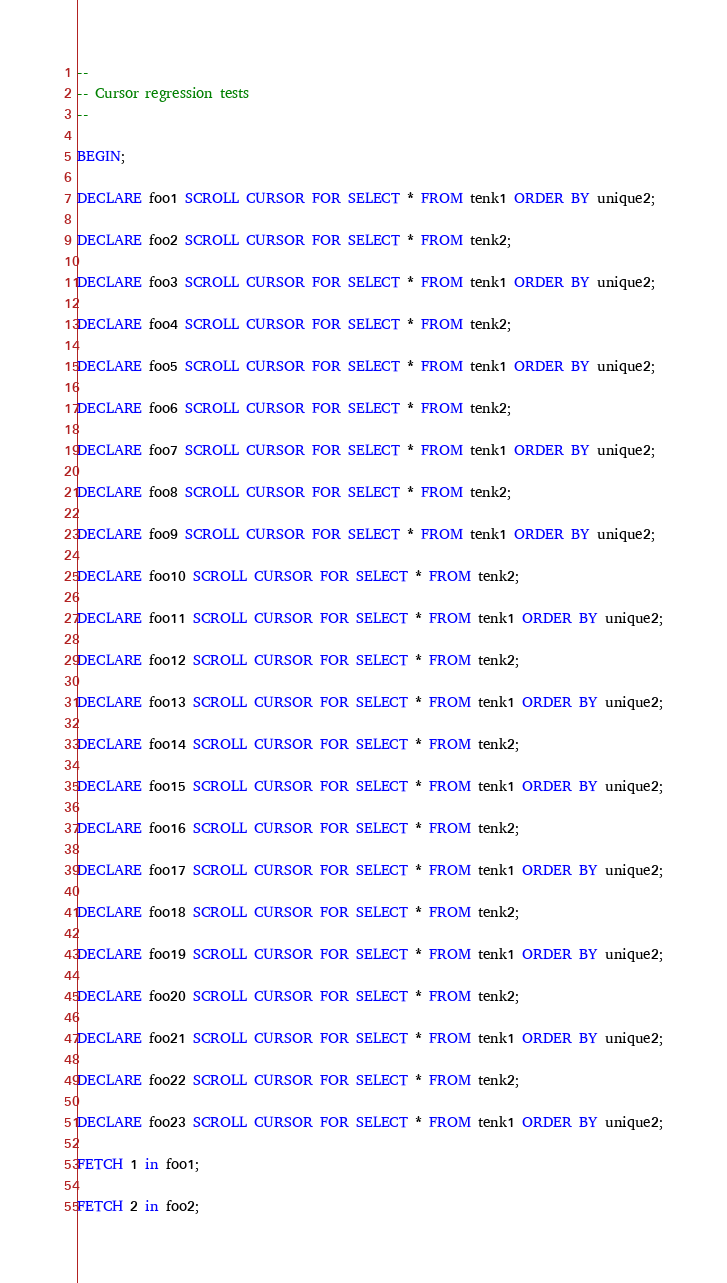Convert code to text. <code><loc_0><loc_0><loc_500><loc_500><_SQL_>--
-- Cursor regression tests
--

BEGIN;

DECLARE foo1 SCROLL CURSOR FOR SELECT * FROM tenk1 ORDER BY unique2;

DECLARE foo2 SCROLL CURSOR FOR SELECT * FROM tenk2;

DECLARE foo3 SCROLL CURSOR FOR SELECT * FROM tenk1 ORDER BY unique2;

DECLARE foo4 SCROLL CURSOR FOR SELECT * FROM tenk2;

DECLARE foo5 SCROLL CURSOR FOR SELECT * FROM tenk1 ORDER BY unique2;

DECLARE foo6 SCROLL CURSOR FOR SELECT * FROM tenk2;

DECLARE foo7 SCROLL CURSOR FOR SELECT * FROM tenk1 ORDER BY unique2;

DECLARE foo8 SCROLL CURSOR FOR SELECT * FROM tenk2;

DECLARE foo9 SCROLL CURSOR FOR SELECT * FROM tenk1 ORDER BY unique2;

DECLARE foo10 SCROLL CURSOR FOR SELECT * FROM tenk2;

DECLARE foo11 SCROLL CURSOR FOR SELECT * FROM tenk1 ORDER BY unique2;

DECLARE foo12 SCROLL CURSOR FOR SELECT * FROM tenk2;

DECLARE foo13 SCROLL CURSOR FOR SELECT * FROM tenk1 ORDER BY unique2;

DECLARE foo14 SCROLL CURSOR FOR SELECT * FROM tenk2;

DECLARE foo15 SCROLL CURSOR FOR SELECT * FROM tenk1 ORDER BY unique2;

DECLARE foo16 SCROLL CURSOR FOR SELECT * FROM tenk2;

DECLARE foo17 SCROLL CURSOR FOR SELECT * FROM tenk1 ORDER BY unique2;

DECLARE foo18 SCROLL CURSOR FOR SELECT * FROM tenk2;

DECLARE foo19 SCROLL CURSOR FOR SELECT * FROM tenk1 ORDER BY unique2;

DECLARE foo20 SCROLL CURSOR FOR SELECT * FROM tenk2;

DECLARE foo21 SCROLL CURSOR FOR SELECT * FROM tenk1 ORDER BY unique2;

DECLARE foo22 SCROLL CURSOR FOR SELECT * FROM tenk2;

DECLARE foo23 SCROLL CURSOR FOR SELECT * FROM tenk1 ORDER BY unique2;

FETCH 1 in foo1;

FETCH 2 in foo2;
</code> 